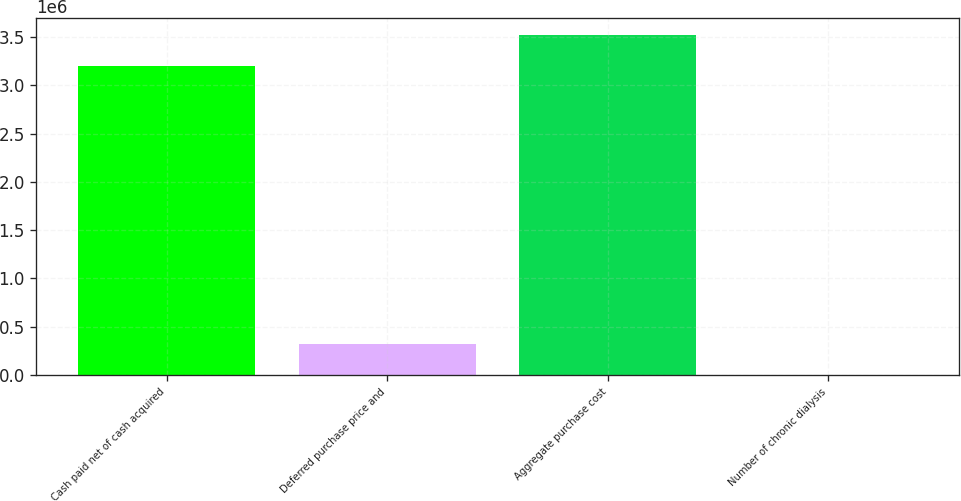Convert chart to OTSL. <chart><loc_0><loc_0><loc_500><loc_500><bar_chart><fcel>Cash paid net of cash acquired<fcel>Deferred purchase price and<fcel>Aggregate purchase cost<fcel>Number of chronic dialysis<nl><fcel>3.2024e+06<fcel>321722<fcel>3.52352e+06<fcel>609<nl></chart> 